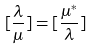<formula> <loc_0><loc_0><loc_500><loc_500>[ \frac { \lambda } { \mu } ] = [ \frac { \mu ^ { * } } { \lambda } ]</formula> 